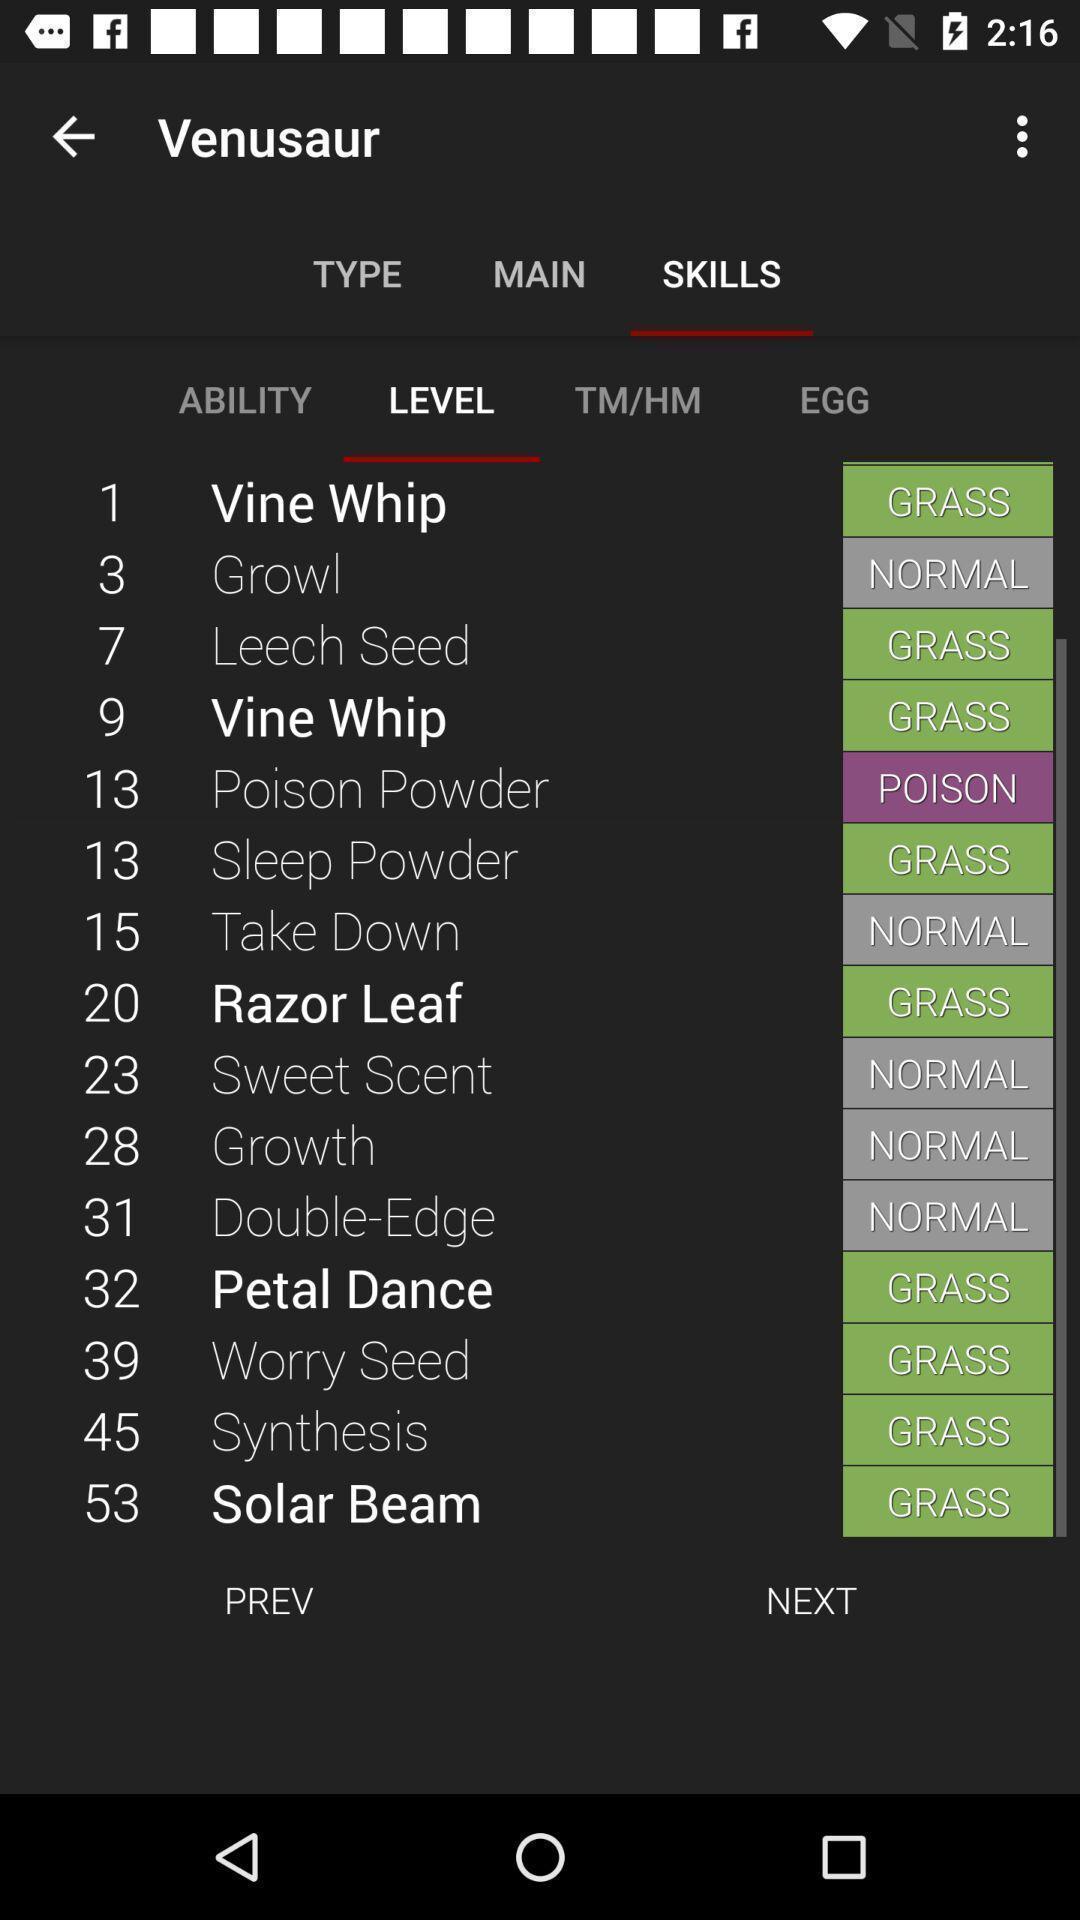Explain the elements present in this screenshot. Screen displaying list of levels in skills. 